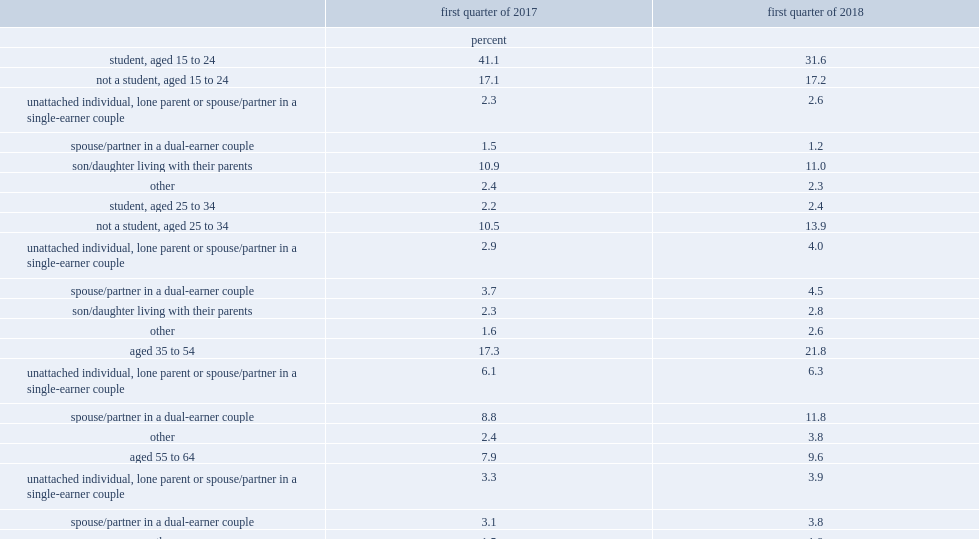How many individuals in total earned minimum wages in the first quarter of 2018? 1565400.0. How many individuals in total earned minimum wages in the first quarter of 2017? 953200.0. What was the proportion of minimum wage workers of all employees in early 2018? 10.1. What was the proportion of minimum wage workers of all employees in early 2017? 6.2. What was the proportion of minimum wage workers that were students aged 15 to 24 in the first quarter of 2017? 41.1. What was the proportion of minimum wage workers that were students aged 15 to 24 in the first quarter of 2018? 31.6. What was the proportion of minimum wage workers that aged 35 to 64 in the first quarter of 2017? 25.2. What was the proportion of minimum wage workers that aged 35 to 64 in the first quarter of 2018? 31.4. What was the proportion difference of minimum wage workers that aged 35 to 64 in the first quarter of 2017 and ealry 2018? 6.2. What was the proportion of minimum wage workers that aged 15 to 24 and non-students the same age living with their parents in early 2018? 42.6. What was the proportion of minimum wage workers that aged 15 to 24 and non-students the same age living with their parents in early 2017? 52. What was the proportion difference of minimum wage workers that were students aged 15 to 24 and non-students the same age living wither their parents in the first quarter of 2017 and ealry 2018? 9.4. 